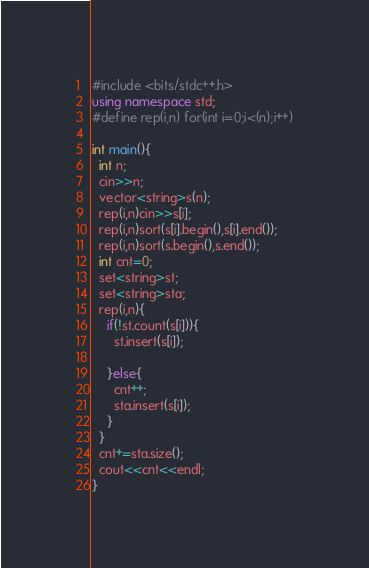<code> <loc_0><loc_0><loc_500><loc_500><_C++_>#include <bits/stdc++.h>
using namespace std;
#define rep(i,n) for(int i=0;i<(n);i++)
 
int main(){
  int n;
  cin>>n;
  vector<string>s(n);
  rep(i,n)cin>>s[i];
  rep(i,n)sort(s[i].begin(),s[i].end());
  rep(i,n)sort(s.begin(),s.end());
  int cnt=0;
  set<string>st;
  set<string>sta;
  rep(i,n){
    if(!st.count(s[i])){
      st.insert(s[i]);
      
    }else{
      cnt++;
      sta.insert(s[i]);
    }
  }
  cnt+=sta.size();
  cout<<cnt<<endl;
}</code> 